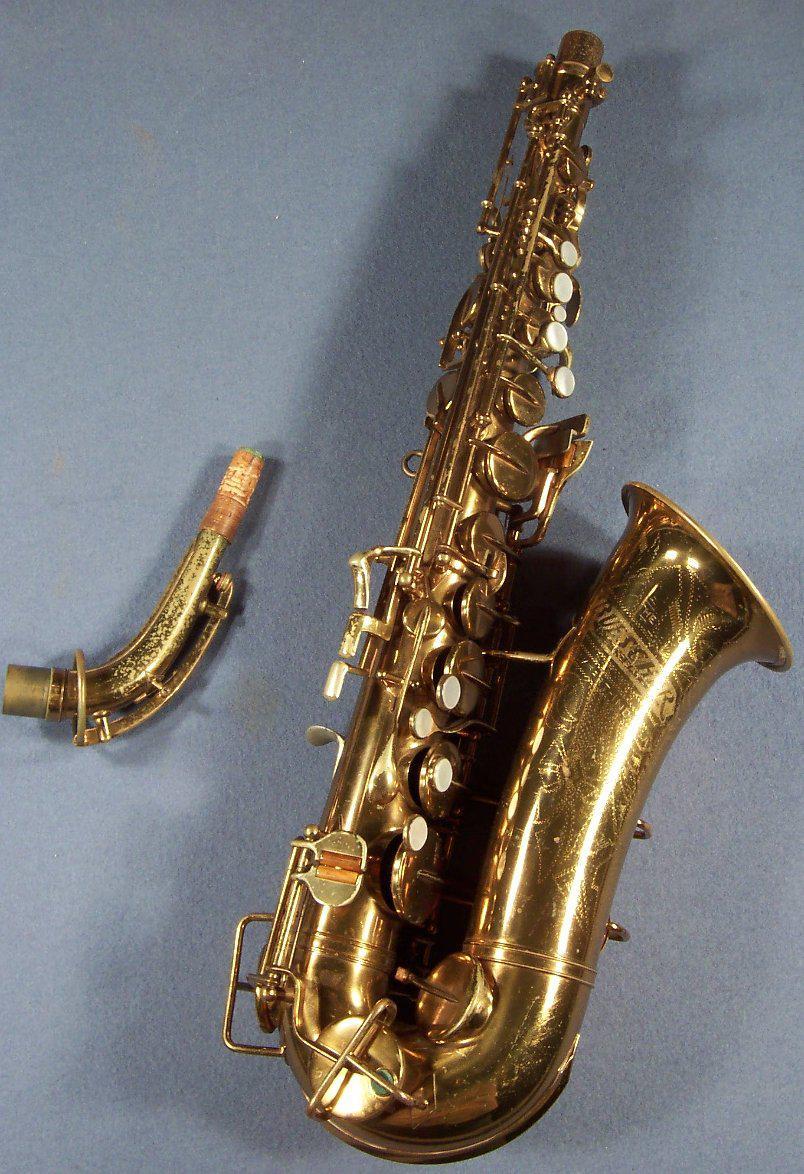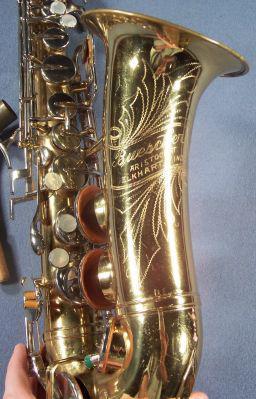The first image is the image on the left, the second image is the image on the right. Analyze the images presented: Is the assertion "One image shows the right-turned engraved bell of saxophone, and the other image shows one saxophone with mouthpiece intact." valid? Answer yes or no. No. The first image is the image on the left, the second image is the image on the right. For the images displayed, is the sentence "All the sax's are facing the same direction." factually correct? Answer yes or no. Yes. 